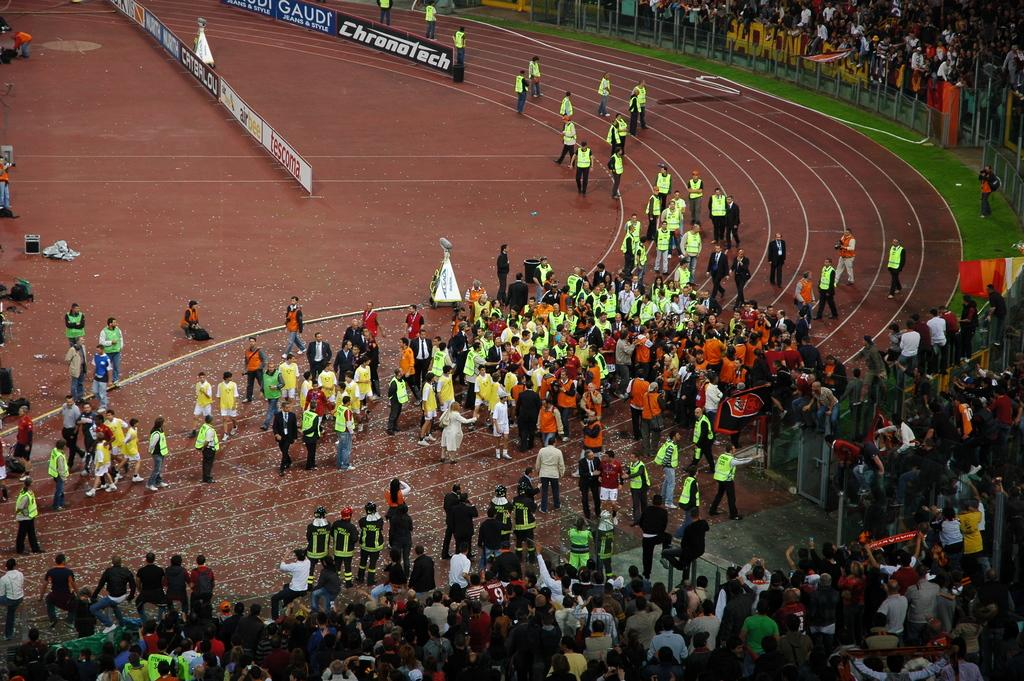What is the main subject of the image? The main subject of the image is a crowd. Where is the flag located in the image? The flag is on the right side of the image. What can be seen in the background of the image? There are boards visible in the background of the image. Reasoning: Let's think step by step by step in order to produce the conversation. We start by identifying the main subject of the image, which is the crowd. Then, we describe the location of the flag, which is on the right side of the image. Finally, we mention the presence of boards in the background of the image. Each question is designed to elicit a specific detail about the image that is known from the provided facts. Absurd Question/Answer: What type of cheese is being used to create the boards in the image? There is no cheese present in the image, and the boards are not made of cheese. What type of cheese is being used to create the boards in the image? There is no cheese present in the image, and the boards are not made of cheese. 